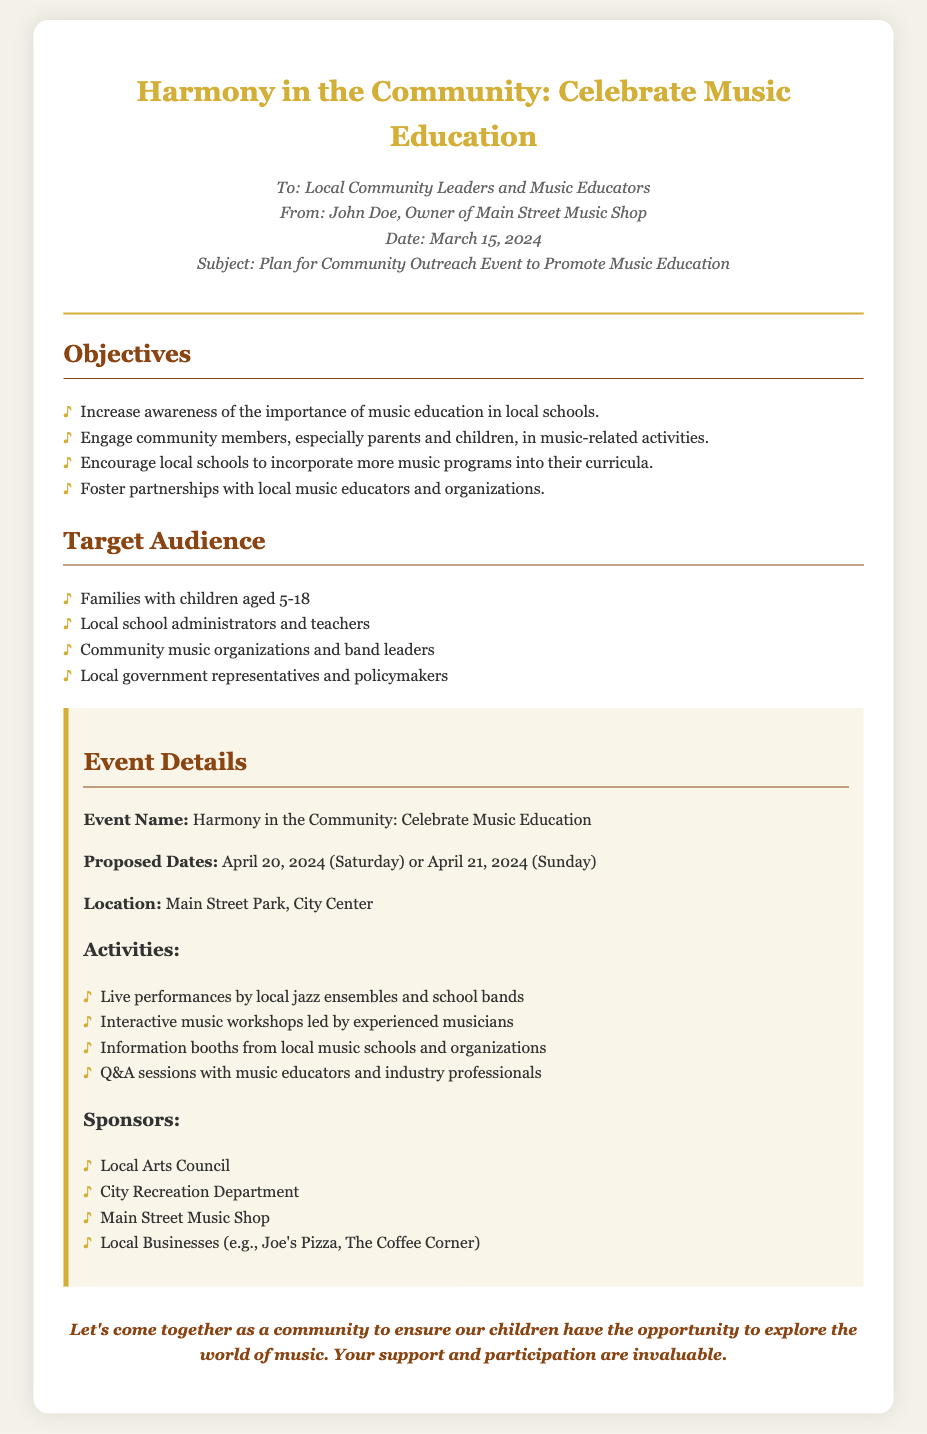What is the title of the event? The title is the first heading in the memo, indicating the theme of the outreach event.
Answer: Harmony in the Community: Celebrate Music Education Who is the memo addressed to? The memo lists the recipients at the beginning under the "To" line, providing clear information about the audience for the memo.
Answer: Local Community Leaders and Music Educators What are the proposed dates for the event? The specific dates for the event are provided in the event details section, highlighting the options for the community gathering.
Answer: April 20, 2024 (Saturday) or April 21, 2024 (Sunday) What is one of the objectives of the event? The objectives are listed under a specific section, indicating the goals of the outreach program aimed at promoting music education.
Answer: Increase awareness of the importance of music education in local schools Who will sponsor the event? The sponsors are listed in a specific section, revealing the organizations and businesses backing the event.
Answer: Local Arts Council What is the location of the event? The memo specifies the location in the event details, making it clear to the audience where the event will take place.
Answer: Main Street Park, City Center What type of activities will take place during the event? The types of activities are outlined under the event details section, showcasing what participants can expect.
Answer: Live performances by local jazz ensembles and school bands What is the main call to action in the memo? The call to action is found at the end of the memo, urging community involvement and support for music education.
Answer: Let's come together as a community to ensure our children have the opportunity to explore the world of music 